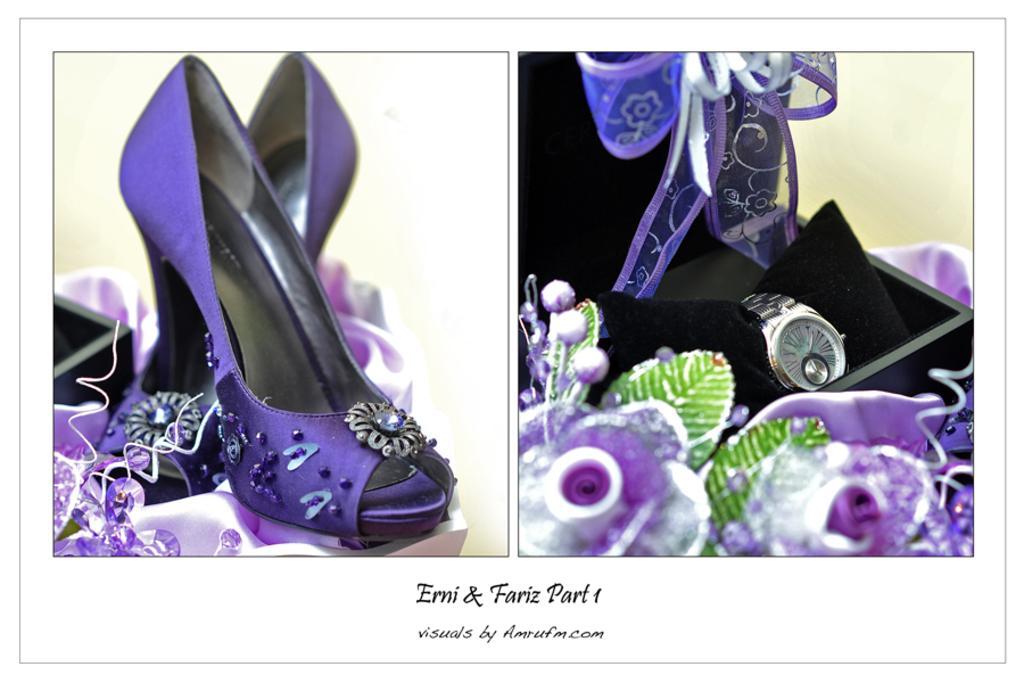In one or two sentences, can you explain what this image depicts? This is an edited image. This image is a collage of two images. On the left side, we see the cut shoes of the woman. It is in purple color. Beside that, we see a black box. On the right side, we see a wrist watch is placed in the black color box. Beside that, we see plastic flowers which are in purple color. At the bottom of the picture, we see some text written in black color. 